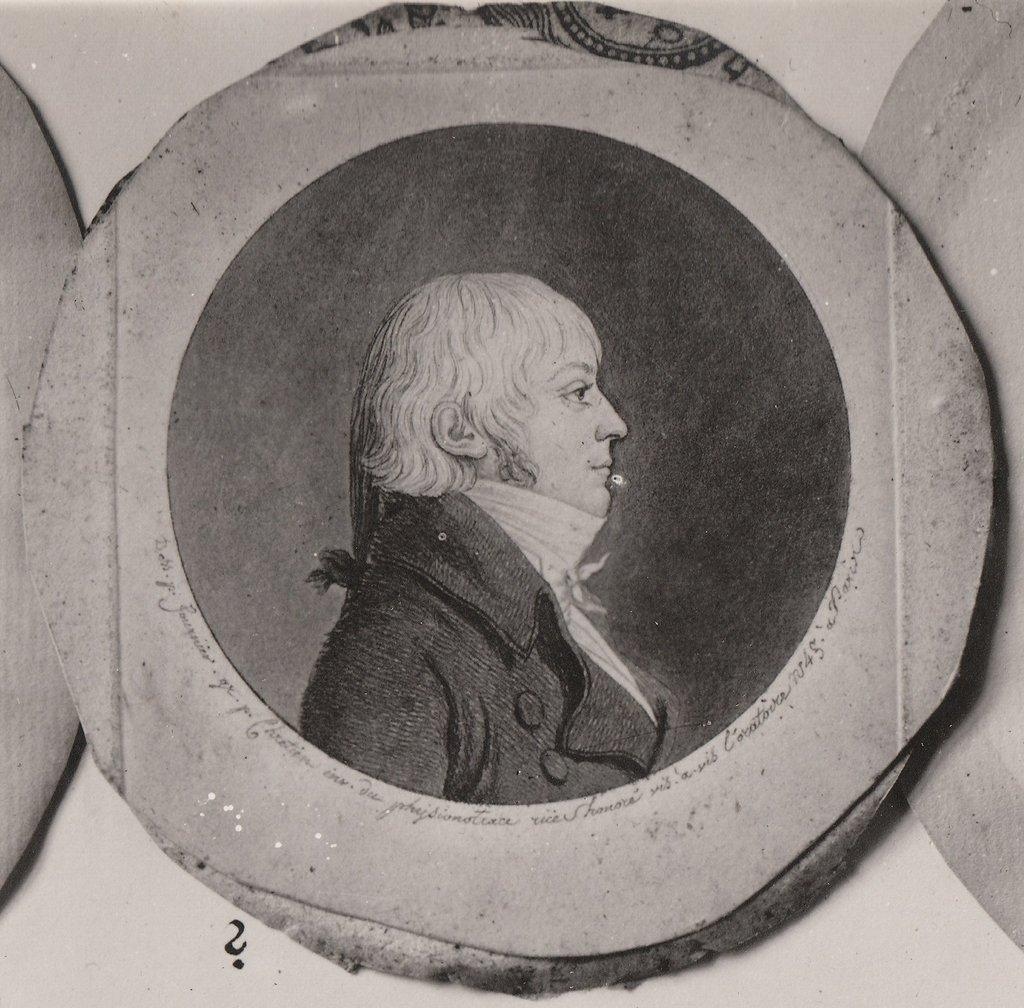What is the color scheme of the image? The image is black and white. Who or what is the main subject in the image? There is a man in the image. Can you describe the object that the man is in? It appears to be a photo frame in the image. Where is the photo frame located? The photo frame is placed on a white wall. What type of feeling does the tank in the image evoke? There is no tank present in the image, so it is not possible to determine the feelings it might evoke. 